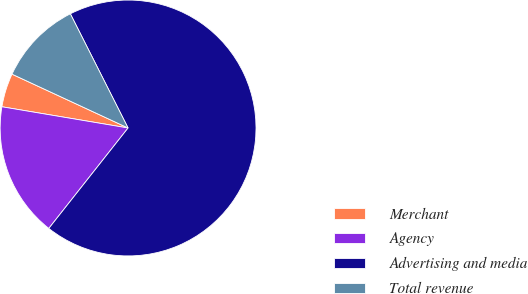Convert chart. <chart><loc_0><loc_0><loc_500><loc_500><pie_chart><fcel>Merchant<fcel>Agency<fcel>Advertising and media<fcel>Total revenue<nl><fcel>4.26%<fcel>17.02%<fcel>68.09%<fcel>10.64%<nl></chart> 